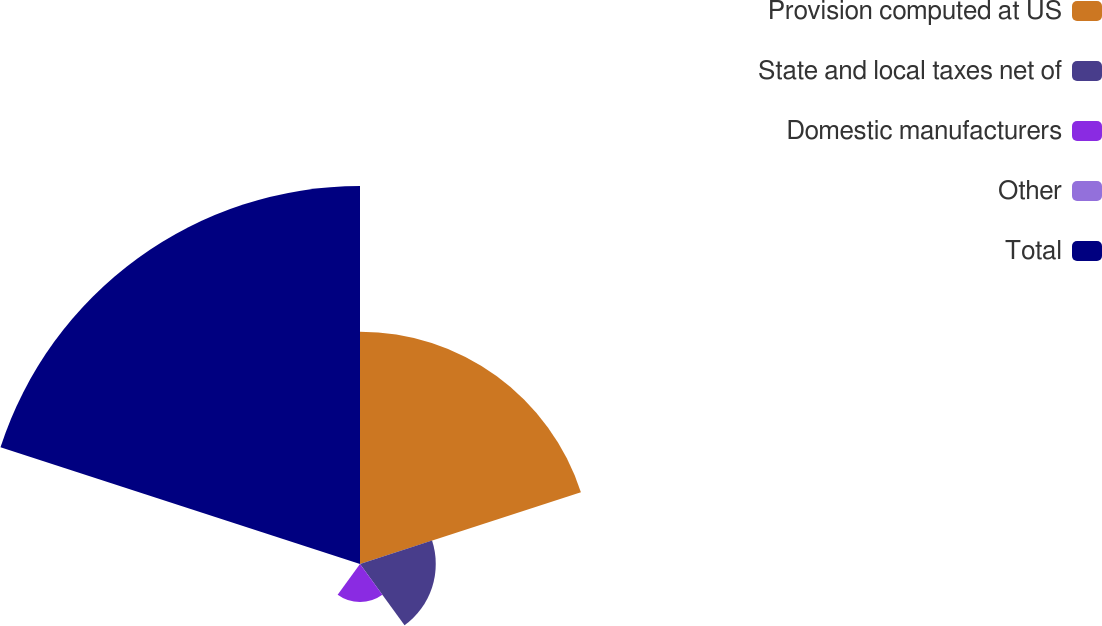Convert chart. <chart><loc_0><loc_0><loc_500><loc_500><pie_chart><fcel>Provision computed at US<fcel>State and local taxes net of<fcel>Domestic manufacturers<fcel>Other<fcel>Total<nl><fcel>32.07%<fcel>10.46%<fcel>5.25%<fcel>0.03%<fcel>52.19%<nl></chart> 